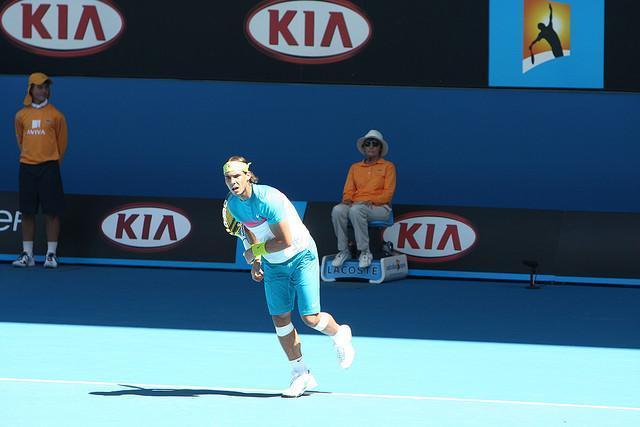How many people are in the picture?
Give a very brief answer. 3. 